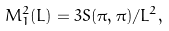<formula> <loc_0><loc_0><loc_500><loc_500>M ^ { 2 } _ { 1 } ( L ) = 3 S ( \pi , \pi ) / L ^ { 2 } ,</formula> 